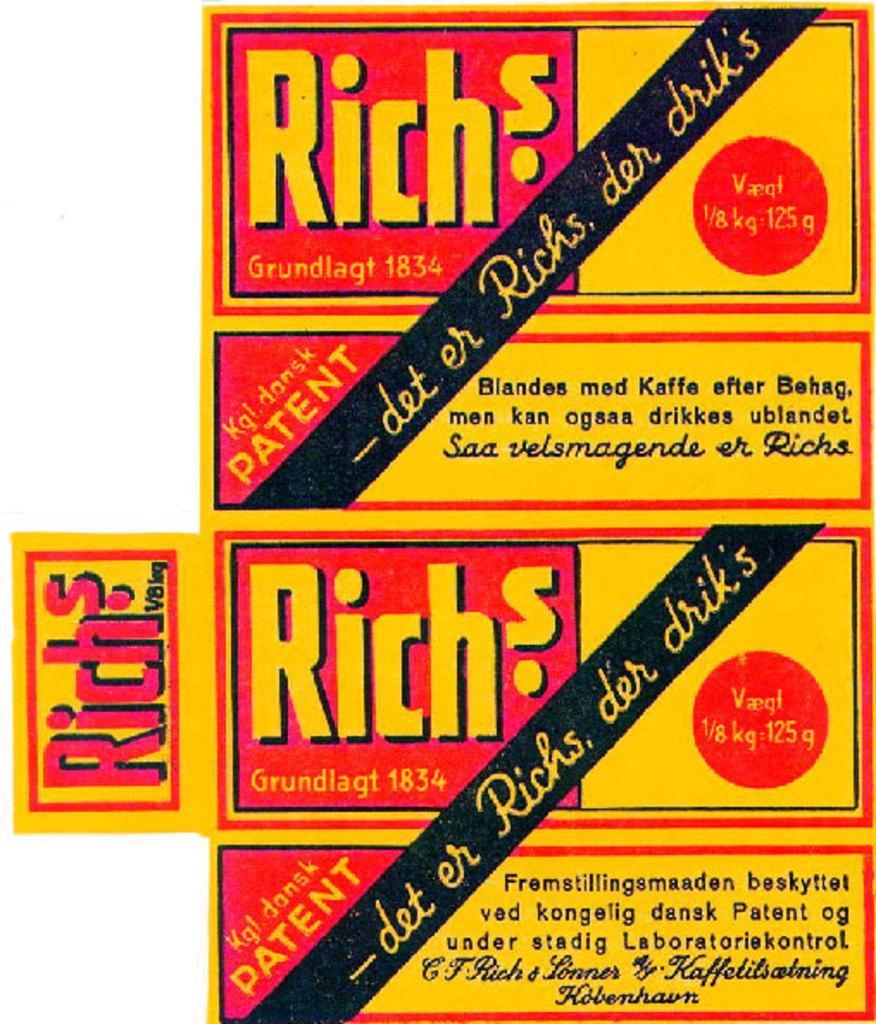Please provide a concise description of this image. In this picture I can see a poster, on which there are words and numbers written and I see that it is white color in the background. 